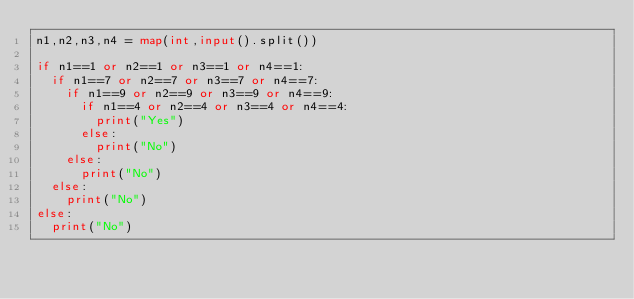Convert code to text. <code><loc_0><loc_0><loc_500><loc_500><_Python_>n1,n2,n3,n4 = map(int,input().split())

if n1==1 or n2==1 or n3==1 or n4==1:
  if n1==7 or n2==7 or n3==7 or n4==7:
    if n1==9 or n2==9 or n3==9 or n4==9:
      if n1==4 or n2==4 or n3==4 or n4==4:
        print("Yes")
      else:
        print("No")
    else:
      print("No")
  else:
    print("No")
else:
  print("No")</code> 